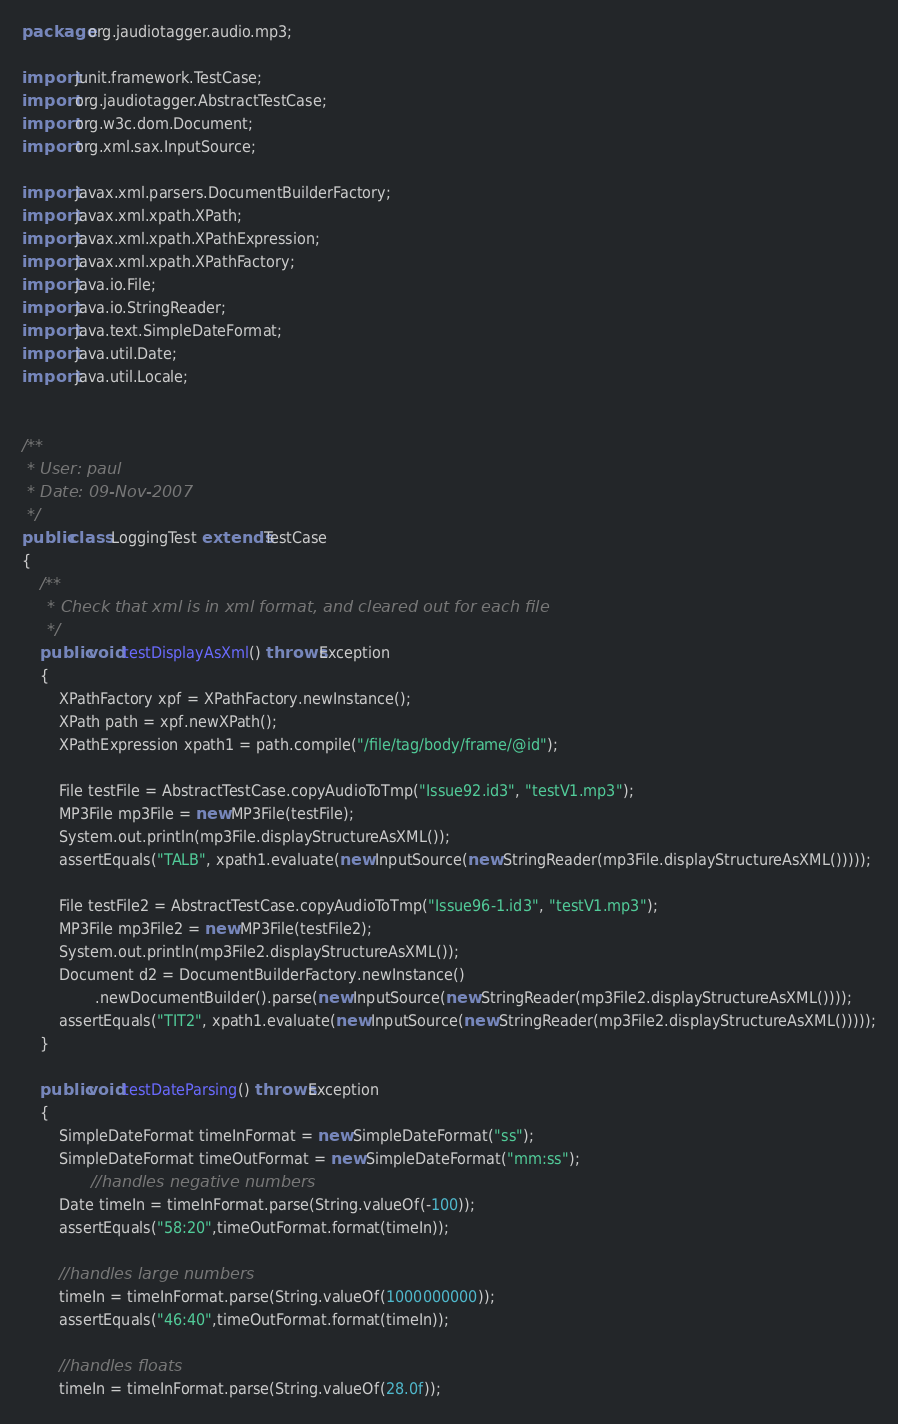<code> <loc_0><loc_0><loc_500><loc_500><_Java_>package org.jaudiotagger.audio.mp3;

import junit.framework.TestCase;
import org.jaudiotagger.AbstractTestCase;
import org.w3c.dom.Document;
import org.xml.sax.InputSource;

import javax.xml.parsers.DocumentBuilderFactory;
import javax.xml.xpath.XPath;
import javax.xml.xpath.XPathExpression;
import javax.xml.xpath.XPathFactory;
import java.io.File;
import java.io.StringReader;
import java.text.SimpleDateFormat;
import java.util.Date;
import java.util.Locale;


/**
 * User: paul
 * Date: 09-Nov-2007
 */
public class LoggingTest extends TestCase
{
    /**
     * Check that xml is in xml format, and cleared out for each file
     */
    public void testDisplayAsXml() throws Exception
    {
        XPathFactory xpf = XPathFactory.newInstance();
        XPath path = xpf.newXPath();
        XPathExpression xpath1 = path.compile("/file/tag/body/frame/@id");

        File testFile = AbstractTestCase.copyAudioToTmp("Issue92.id3", "testV1.mp3");
        MP3File mp3File = new MP3File(testFile);
        System.out.println(mp3File.displayStructureAsXML());
        assertEquals("TALB", xpath1.evaluate(new InputSource(new StringReader(mp3File.displayStructureAsXML()))));

        File testFile2 = AbstractTestCase.copyAudioToTmp("Issue96-1.id3", "testV1.mp3");
        MP3File mp3File2 = new MP3File(testFile2);
        System.out.println(mp3File2.displayStructureAsXML());
        Document d2 = DocumentBuilderFactory.newInstance()
                .newDocumentBuilder().parse(new InputSource(new StringReader(mp3File2.displayStructureAsXML())));
        assertEquals("TIT2", xpath1.evaluate(new InputSource(new StringReader(mp3File2.displayStructureAsXML()))));
    }

    public void testDateParsing() throws Exception
    {
        SimpleDateFormat timeInFormat = new SimpleDateFormat("ss");
        SimpleDateFormat timeOutFormat = new SimpleDateFormat("mm:ss");
               //handles negative numbers
        Date timeIn = timeInFormat.parse(String.valueOf(-100));
        assertEquals("58:20",timeOutFormat.format(timeIn));

        //handles large numbers
        timeIn = timeInFormat.parse(String.valueOf(1000000000));
        assertEquals("46:40",timeOutFormat.format(timeIn));

        //handles floats
        timeIn = timeInFormat.parse(String.valueOf(28.0f));</code> 